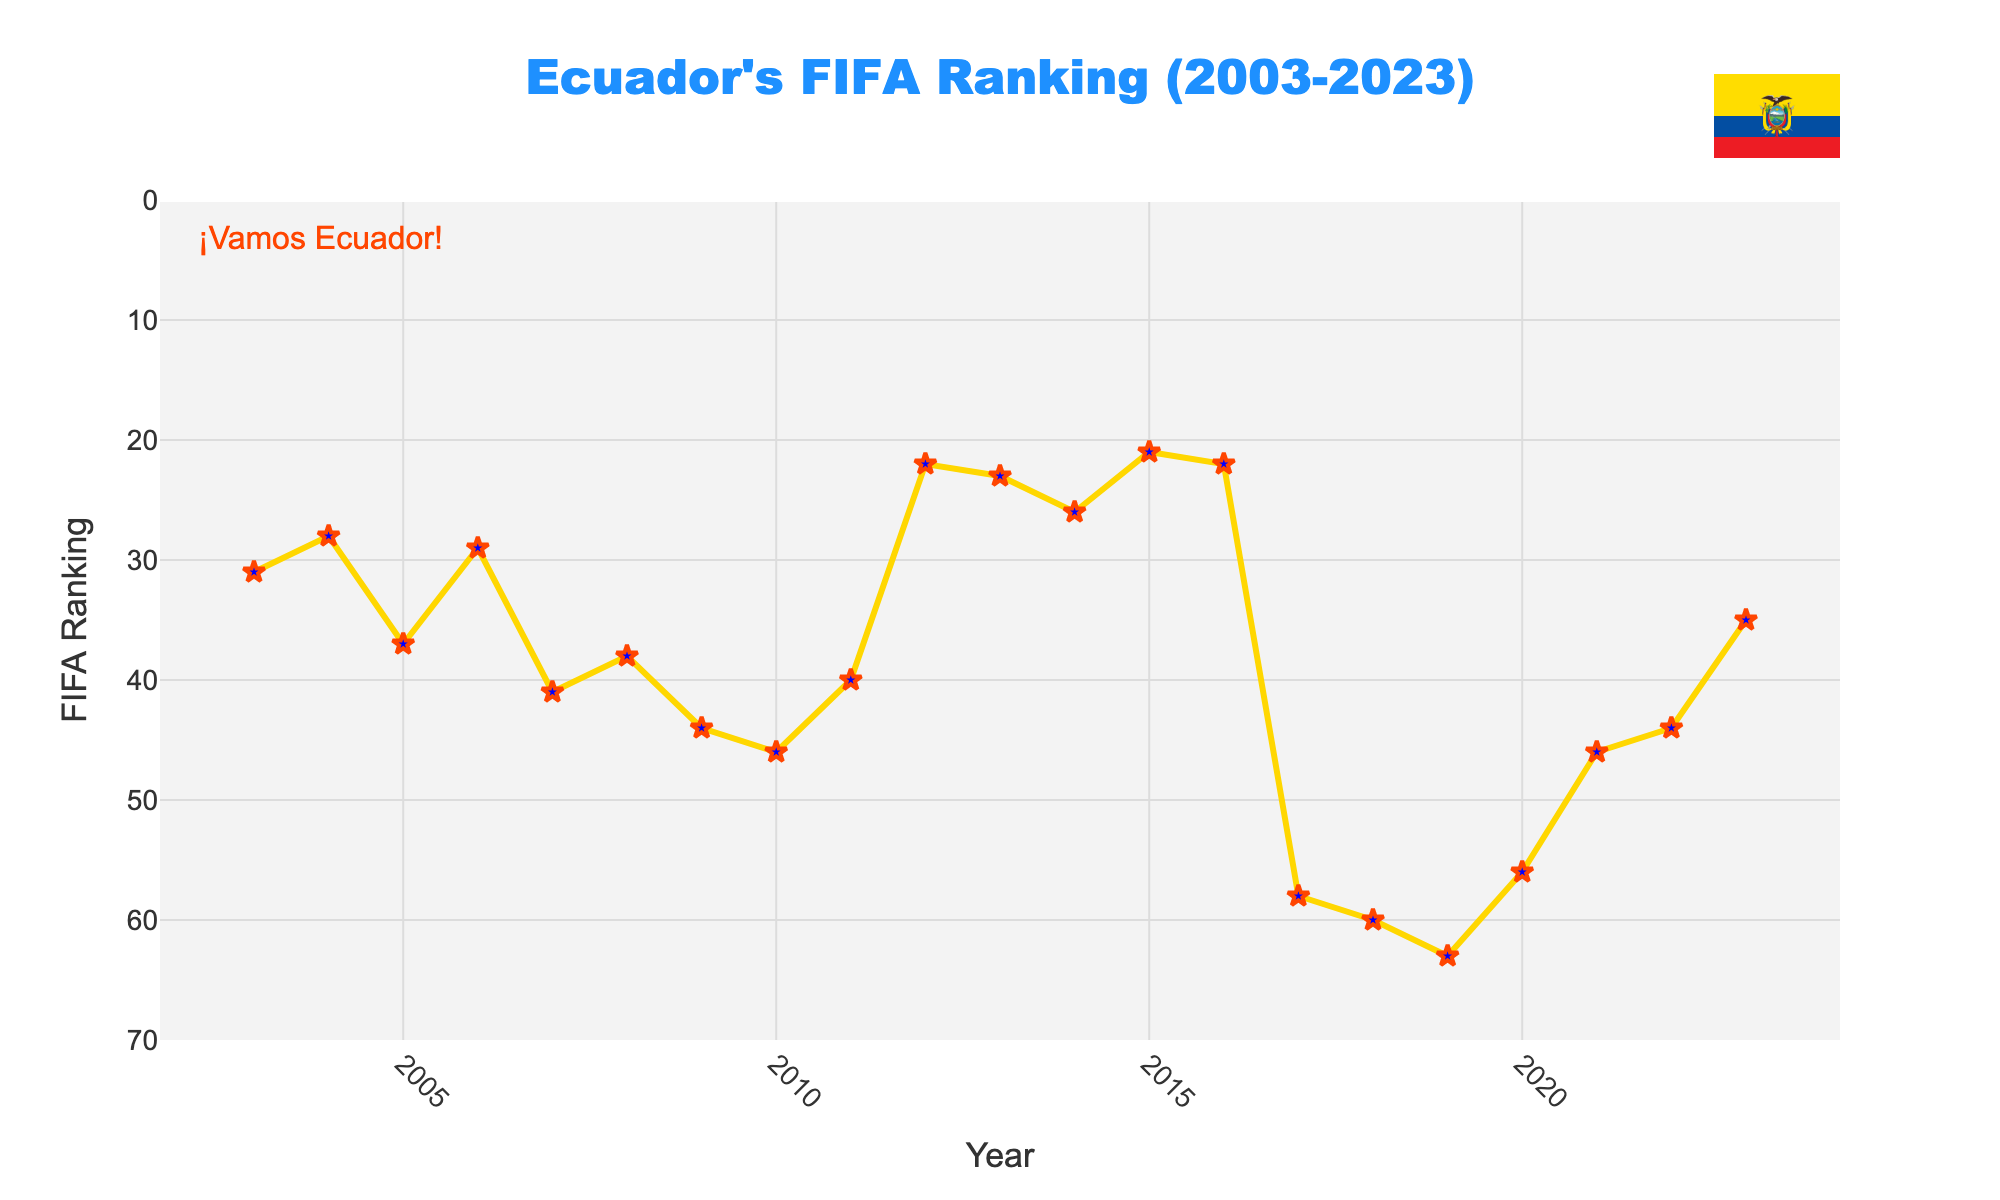Which year did Ecuador achieve its best FIFA ranking? The best FIFA ranking can be identified by finding the year with the lowest ranking position in the dataset. Inspecting the line chart, the lowest ranking (highest performance) is at 21 in the year 2015.
Answer: 2015 What is the average FIFA ranking of Ecuador over the past 20 years? To calculate the average FIFA ranking, sum up all the rankings and divide by the number of years. The sum of rankings from 2003 to 2023 is 744 and there are 20 years. So, the average is 744/20.
Answer: 37.2 Which two consecutive years showed the largest improvement in ranking? To determine the largest improvement, look for the steepest downward slope in the line chart. The largest drop in ranking is observed between 2011 (40) and 2012 (22), an improvement of 18 positions.
Answer: 2011 to 2012 What was Ecuador's FIFA ranking in the year they peaked then dropped drastically the following year? From the chart, identify the year with a peak followed by a significant drop. Ecuador ranked 22 in 2016 and dropped to 58 in 2017.
Answer: 2016 In which year did Ecuador's FIFA ranking first exceed 40? Look for the first point on the graph where the ranking exceeds (is greater than) 40. This occurred in 2007 where the ranking was 41.
Answer: 2007 Which period showed a consistent decline in Ecuador's FIFA ranking for five consecutive years? Check for a continuous rising trend in the FIFA ranking for a duration of five years. From 2005 (37) to 2010 (46), the ranking showed a consistent decline.
Answer: 2005 to 2010 How many times did Ecuador's FIFA ranking improve consecutively for two years or more? Count the sequences on the chart where the ranking improves for at least two consecutive years. There are two sequences: 2003 to 2004, and 2013 to 2015.
Answer: 2 times Is the FIFA ranking in 2023 higher or lower compared to the year 2003? Compare the FIFA ranking values in the years 2023 (35) and 2003 (31). In 2023, the ranking is higher (worse).
Answer: Higher What is the range of Ecuador’s FIFA ranking over the past 20 years? The range is the difference between the maximum and the minimum ranking. The maximum ranking is 63 (in 2019) and the minimum ranking is 21 (in 2015). The range is 63 - 21.
Answer: 42 During which three-year period did Ecuador consistently hover around the mid-20s in their FIFA ranking? Identify a three-year span where the FIFA ranking remains in the mid-20s. The period from 2013 (23) to 2015 (21) shows this consistency.
Answer: 2013 to 2015 